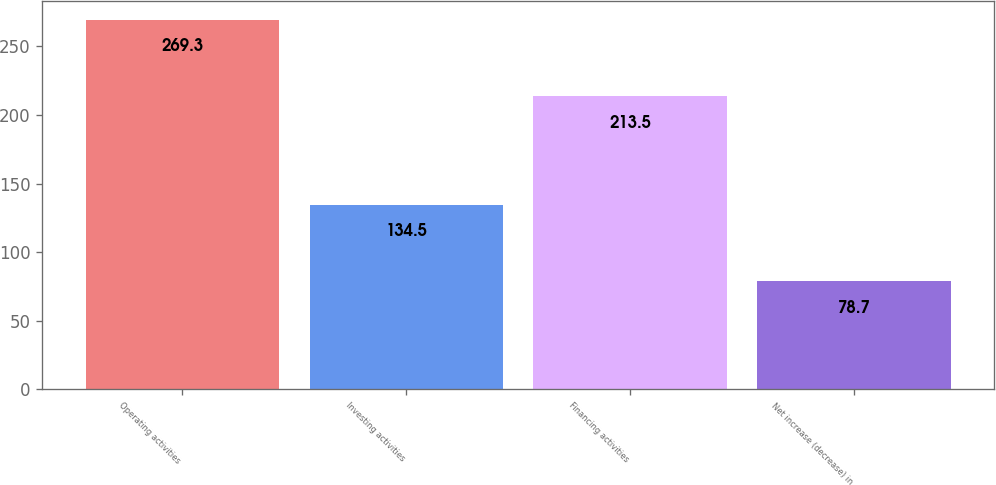Convert chart to OTSL. <chart><loc_0><loc_0><loc_500><loc_500><bar_chart><fcel>Operating activities<fcel>Investing activities<fcel>Financing activities<fcel>Net increase (decrease) in<nl><fcel>269.3<fcel>134.5<fcel>213.5<fcel>78.7<nl></chart> 